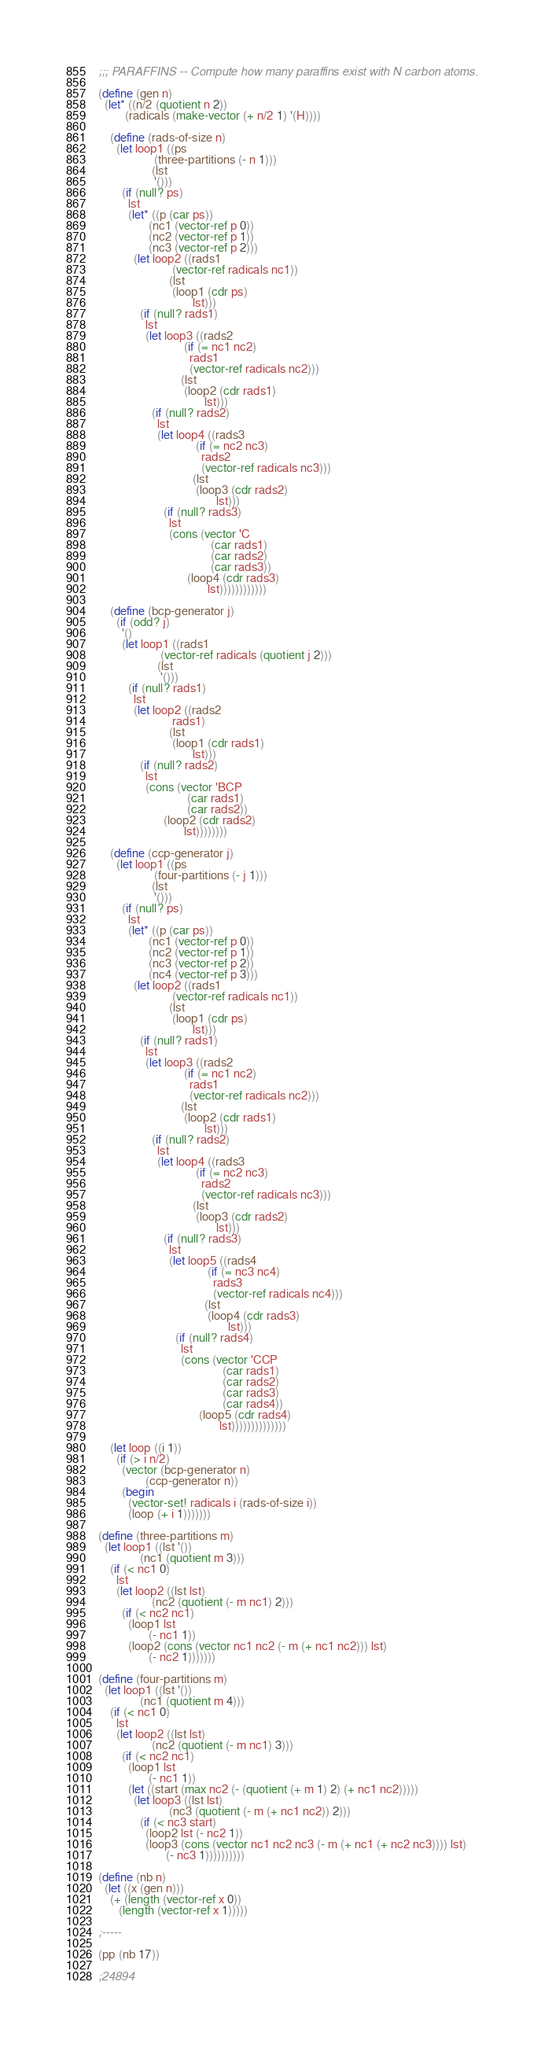Convert code to text. <code><loc_0><loc_0><loc_500><loc_500><_Scheme_>;;; PARAFFINS -- Compute how many paraffins exist with N carbon atoms.

(define (gen n)
  (let* ((n/2 (quotient n 2))
         (radicals (make-vector (+ n/2 1) '(H))))

    (define (rads-of-size n)
      (let loop1 ((ps
                   (three-partitions (- n 1)))
                  (lst
                   '()))
        (if (null? ps)
          lst
          (let* ((p (car ps))
                 (nc1 (vector-ref p 0))
                 (nc2 (vector-ref p 1))
                 (nc3 (vector-ref p 2)))
            (let loop2 ((rads1
                         (vector-ref radicals nc1))
                        (lst
                         (loop1 (cdr ps)
                                lst)))
              (if (null? rads1)
                lst
                (let loop3 ((rads2
                             (if (= nc1 nc2)
                               rads1
                               (vector-ref radicals nc2)))
                            (lst
                             (loop2 (cdr rads1)
                                    lst)))
                  (if (null? rads2)
                    lst
                    (let loop4 ((rads3
                                 (if (= nc2 nc3)
                                   rads2
                                   (vector-ref radicals nc3)))
                                (lst
                                 (loop3 (cdr rads2)
                                        lst)))
                      (if (null? rads3)
                        lst
                        (cons (vector 'C
                                      (car rads1)
                                      (car rads2)
                                      (car rads3))
                              (loop4 (cdr rads3)
                                     lst))))))))))))

    (define (bcp-generator j)
      (if (odd? j)
        '()
        (let loop1 ((rads1
                     (vector-ref radicals (quotient j 2)))
                    (lst
                     '()))
          (if (null? rads1)
            lst
            (let loop2 ((rads2
                         rads1)
                        (lst
                         (loop1 (cdr rads1)
                                lst)))
              (if (null? rads2)
                lst
                (cons (vector 'BCP
                              (car rads1)
                              (car rads2))
                      (loop2 (cdr rads2)
                             lst))))))))

    (define (ccp-generator j)
      (let loop1 ((ps
                   (four-partitions (- j 1)))
                  (lst
                   '()))
        (if (null? ps)
          lst
          (let* ((p (car ps))
                 (nc1 (vector-ref p 0))
                 (nc2 (vector-ref p 1))
                 (nc3 (vector-ref p 2))
                 (nc4 (vector-ref p 3)))
            (let loop2 ((rads1
                         (vector-ref radicals nc1))
                        (lst
                         (loop1 (cdr ps)
                                lst)))
              (if (null? rads1)
                lst
                (let loop3 ((rads2
                             (if (= nc1 nc2)
                               rads1
                               (vector-ref radicals nc2)))
                            (lst
                             (loop2 (cdr rads1)
                                    lst)))
                  (if (null? rads2)
                    lst
                    (let loop4 ((rads3
                                 (if (= nc2 nc3)
                                   rads2
                                   (vector-ref radicals nc3)))
                                (lst
                                 (loop3 (cdr rads2)
                                        lst)))
                      (if (null? rads3)
                        lst
                        (let loop5 ((rads4
                                     (if (= nc3 nc4)
                                       rads3
                                       (vector-ref radicals nc4)))
                                    (lst
                                     (loop4 (cdr rads3)
                                            lst)))
                          (if (null? rads4)
                            lst
                            (cons (vector 'CCP
                                          (car rads1)
                                          (car rads2)
                                          (car rads3)
                                          (car rads4))
                                  (loop5 (cdr rads4)
                                         lst))))))))))))))

    (let loop ((i 1))
      (if (> i n/2)
        (vector (bcp-generator n)
                (ccp-generator n))
        (begin
          (vector-set! radicals i (rads-of-size i))
          (loop (+ i 1)))))))

(define (three-partitions m)
  (let loop1 ((lst '())
              (nc1 (quotient m 3)))
    (if (< nc1 0)
      lst
      (let loop2 ((lst lst)
                  (nc2 (quotient (- m nc1) 2)))
        (if (< nc2 nc1)
          (loop1 lst
                 (- nc1 1))
          (loop2 (cons (vector nc1 nc2 (- m (+ nc1 nc2))) lst)
                 (- nc2 1)))))))

(define (four-partitions m)
  (let loop1 ((lst '())
              (nc1 (quotient m 4)))
    (if (< nc1 0)
      lst
      (let loop2 ((lst lst)
                  (nc2 (quotient (- m nc1) 3)))
        (if (< nc2 nc1)
          (loop1 lst
                 (- nc1 1))
          (let ((start (max nc2 (- (quotient (+ m 1) 2) (+ nc1 nc2)))))
            (let loop3 ((lst lst)
                        (nc3 (quotient (- m (+ nc1 nc2)) 2)))
              (if (< nc3 start)
                (loop2 lst (- nc2 1))
                (loop3 (cons (vector nc1 nc2 nc3 (- m (+ nc1 (+ nc2 nc3)))) lst)
                       (- nc3 1))))))))))

(define (nb n)
  (let ((x (gen n)))
    (+ (length (vector-ref x 0))
       (length (vector-ref x 1)))))

;-----

(pp (nb 17))

;24894
</code> 